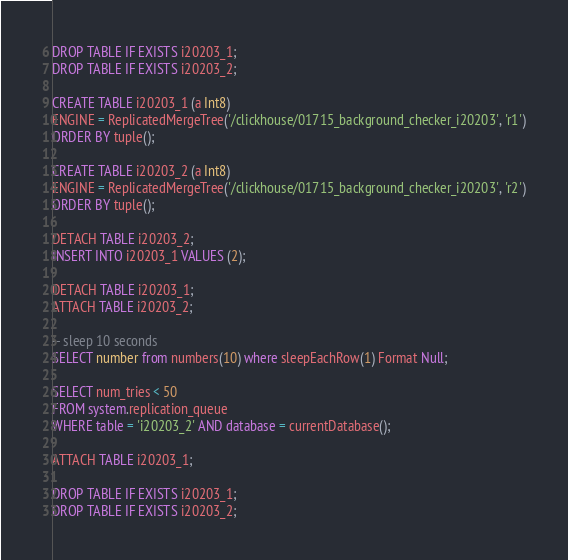Convert code to text. <code><loc_0><loc_0><loc_500><loc_500><_SQL_>DROP TABLE IF EXISTS i20203_1;
DROP TABLE IF EXISTS i20203_2;

CREATE TABLE i20203_1 (a Int8)
ENGINE = ReplicatedMergeTree('/clickhouse/01715_background_checker_i20203', 'r1')
ORDER BY tuple();

CREATE TABLE i20203_2 (a Int8)
ENGINE = ReplicatedMergeTree('/clickhouse/01715_background_checker_i20203', 'r2')
ORDER BY tuple();

DETACH TABLE i20203_2;
INSERT INTO i20203_1 VALUES (2);

DETACH TABLE i20203_1;
ATTACH TABLE i20203_2;

-- sleep 10 seconds
SELECT number from numbers(10) where sleepEachRow(1) Format Null;

SELECT num_tries < 50
FROM system.replication_queue
WHERE table = 'i20203_2' AND database = currentDatabase();

ATTACH TABLE i20203_1;

DROP TABLE IF EXISTS i20203_1;
DROP TABLE IF EXISTS i20203_2;
</code> 